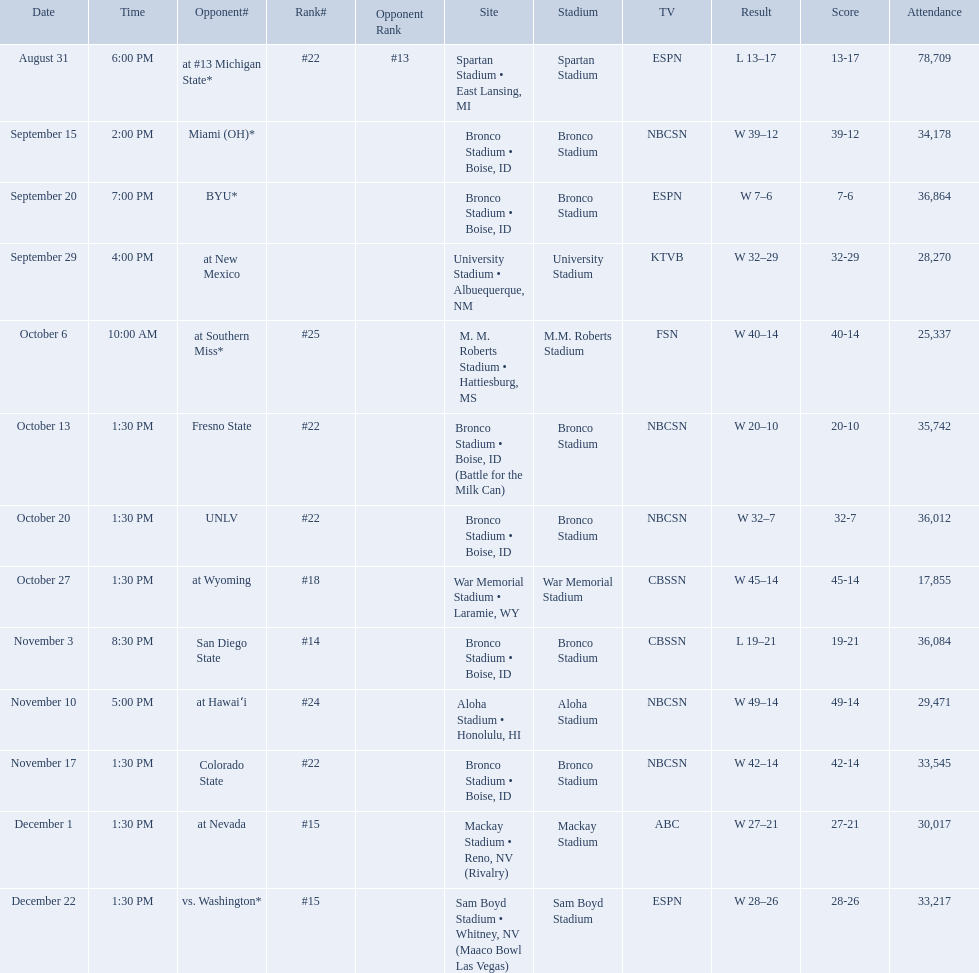What was the team's listed rankings for the season? #22, , , , #25, #22, #22, #18, #14, #24, #22, #15, #15. Which of these ranks is the best? #14. What are all of the rankings? #22, , , , #25, #22, #22, #18, #14, #24, #22, #15, #15. Which of them was the best position? #14. Write the full table. {'header': ['Date', 'Time', 'Opponent#', 'Rank#', 'Opponent Rank', 'Site', 'Stadium', 'TV', 'Result', 'Score', 'Attendance'], 'rows': [['August 31', '6:00 PM', 'at\xa0#13\xa0Michigan State*', '#22', '#13', 'Spartan Stadium • East Lansing, MI', 'Spartan Stadium', 'ESPN', 'L\xa013–17', '13-17', '78,709'], ['September 15', '2:00 PM', 'Miami (OH)*', '', '', 'Bronco Stadium • Boise, ID', 'Bronco Stadium', 'NBCSN', 'W\xa039–12', '39-12', '34,178'], ['September 20', '7:00 PM', 'BYU*', '', '', 'Bronco Stadium • Boise, ID', 'Bronco Stadium', 'ESPN', 'W\xa07–6', '7-6', '36,864'], ['September 29', '4:00 PM', 'at\xa0New Mexico', '', '', 'University Stadium • Albuequerque, NM', 'University Stadium', 'KTVB', 'W\xa032–29', '32-29', '28,270'], ['October 6', '10:00 AM', 'at\xa0Southern Miss*', '#25', '', 'M. M. Roberts Stadium • Hattiesburg, MS', 'M.M. Roberts Stadium', 'FSN', 'W\xa040–14', '40-14', '25,337'], ['October 13', '1:30 PM', 'Fresno State', '#22', '', 'Bronco Stadium • Boise, ID (Battle for the Milk Can)', 'Bronco Stadium', 'NBCSN', 'W\xa020–10', '20-10', '35,742'], ['October 20', '1:30 PM', 'UNLV', '#22', '', 'Bronco Stadium • Boise, ID', 'Bronco Stadium', 'NBCSN', 'W\xa032–7', '32-7', '36,012'], ['October 27', '1:30 PM', 'at\xa0Wyoming', '#18', '', 'War Memorial Stadium • Laramie, WY', 'War Memorial Stadium', 'CBSSN', 'W\xa045–14', '45-14', '17,855'], ['November 3', '8:30 PM', 'San Diego State', '#14', '', 'Bronco Stadium • Boise, ID', 'Bronco Stadium', 'CBSSN', 'L\xa019–21', '19-21', '36,084'], ['November 10', '5:00 PM', 'at\xa0Hawaiʻi', '#24', '', 'Aloha Stadium • Honolulu, HI', 'Aloha Stadium', 'NBCSN', 'W\xa049–14', '49-14', '29,471'], ['November 17', '1:30 PM', 'Colorado State', '#22', '', 'Bronco Stadium • Boise, ID', 'Bronco Stadium', 'NBCSN', 'W\xa042–14', '42-14', '33,545'], ['December 1', '1:30 PM', 'at\xa0Nevada', '#15', '', 'Mackay Stadium • Reno, NV (Rivalry)', 'Mackay Stadium', 'ABC', 'W\xa027–21', '27-21', '30,017'], ['December 22', '1:30 PM', 'vs.\xa0Washington*', '#15', '', 'Sam Boyd Stadium • Whitney, NV (Maaco Bowl Las Vegas)', 'Sam Boyd Stadium', 'ESPN', 'W\xa028–26', '28-26', '33,217']]} What are the opponent teams of the 2012 boise state broncos football team? At #13 michigan state*, miami (oh)*, byu*, at new mexico, at southern miss*, fresno state, unlv, at wyoming, san diego state, at hawaiʻi, colorado state, at nevada, vs. washington*. How has the highest rank of these opponents? San Diego State. Can you give me this table in json format? {'header': ['Date', 'Time', 'Opponent#', 'Rank#', 'Opponent Rank', 'Site', 'Stadium', 'TV', 'Result', 'Score', 'Attendance'], 'rows': [['August 31', '6:00 PM', 'at\xa0#13\xa0Michigan State*', '#22', '#13', 'Spartan Stadium • East Lansing, MI', 'Spartan Stadium', 'ESPN', 'L\xa013–17', '13-17', '78,709'], ['September 15', '2:00 PM', 'Miami (OH)*', '', '', 'Bronco Stadium • Boise, ID', 'Bronco Stadium', 'NBCSN', 'W\xa039–12', '39-12', '34,178'], ['September 20', '7:00 PM', 'BYU*', '', '', 'Bronco Stadium • Boise, ID', 'Bronco Stadium', 'ESPN', 'W\xa07–6', '7-6', '36,864'], ['September 29', '4:00 PM', 'at\xa0New Mexico', '', '', 'University Stadium • Albuequerque, NM', 'University Stadium', 'KTVB', 'W\xa032–29', '32-29', '28,270'], ['October 6', '10:00 AM', 'at\xa0Southern Miss*', '#25', '', 'M. M. Roberts Stadium • Hattiesburg, MS', 'M.M. Roberts Stadium', 'FSN', 'W\xa040–14', '40-14', '25,337'], ['October 13', '1:30 PM', 'Fresno State', '#22', '', 'Bronco Stadium • Boise, ID (Battle for the Milk Can)', 'Bronco Stadium', 'NBCSN', 'W\xa020–10', '20-10', '35,742'], ['October 20', '1:30 PM', 'UNLV', '#22', '', 'Bronco Stadium • Boise, ID', 'Bronco Stadium', 'NBCSN', 'W\xa032–7', '32-7', '36,012'], ['October 27', '1:30 PM', 'at\xa0Wyoming', '#18', '', 'War Memorial Stadium • Laramie, WY', 'War Memorial Stadium', 'CBSSN', 'W\xa045–14', '45-14', '17,855'], ['November 3', '8:30 PM', 'San Diego State', '#14', '', 'Bronco Stadium • Boise, ID', 'Bronco Stadium', 'CBSSN', 'L\xa019–21', '19-21', '36,084'], ['November 10', '5:00 PM', 'at\xa0Hawaiʻi', '#24', '', 'Aloha Stadium • Honolulu, HI', 'Aloha Stadium', 'NBCSN', 'W\xa049–14', '49-14', '29,471'], ['November 17', '1:30 PM', 'Colorado State', '#22', '', 'Bronco Stadium • Boise, ID', 'Bronco Stadium', 'NBCSN', 'W\xa042–14', '42-14', '33,545'], ['December 1', '1:30 PM', 'at\xa0Nevada', '#15', '', 'Mackay Stadium • Reno, NV (Rivalry)', 'Mackay Stadium', 'ABC', 'W\xa027–21', '27-21', '30,017'], ['December 22', '1:30 PM', 'vs.\xa0Washington*', '#15', '', 'Sam Boyd Stadium • Whitney, NV (Maaco Bowl Las Vegas)', 'Sam Boyd Stadium', 'ESPN', 'W\xa028–26', '28-26', '33,217']]} 